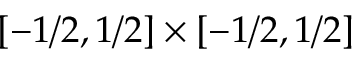Convert formula to latex. <formula><loc_0><loc_0><loc_500><loc_500>[ - 1 / 2 , 1 / 2 ] \times [ - 1 / 2 , 1 / 2 ]</formula> 